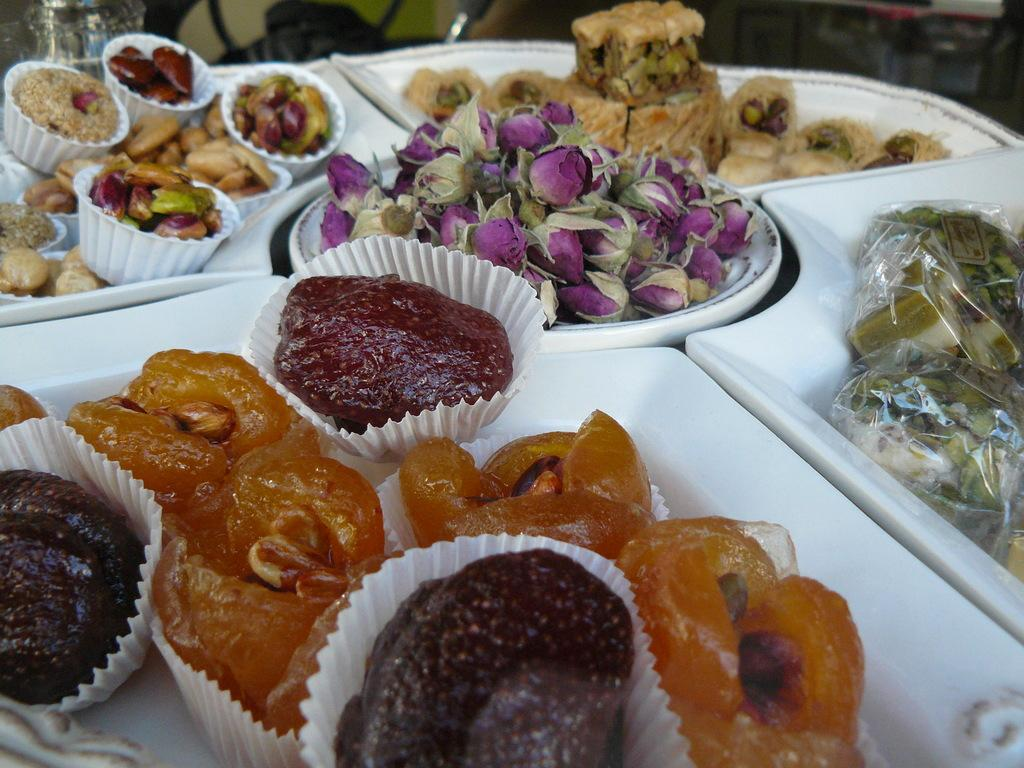What type of flowers can be seen in the image? There are roses in the image. What type of desserts are present in the image? There are cakes and sweets in the image. What are the food items in the image served in? The food items are served in paper bowls and on plates in the image. What shapes do the clocks have in the image? There are no clocks present in the image. What is the limit of the desserts in the image? There is no indication of a limit on the desserts in the image. 